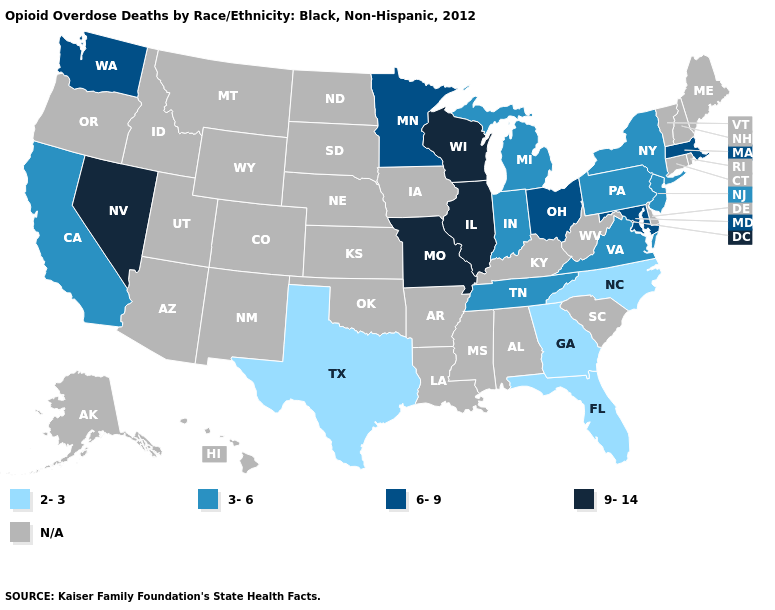Name the states that have a value in the range N/A?
Answer briefly. Alabama, Alaska, Arizona, Arkansas, Colorado, Connecticut, Delaware, Hawaii, Idaho, Iowa, Kansas, Kentucky, Louisiana, Maine, Mississippi, Montana, Nebraska, New Hampshire, New Mexico, North Dakota, Oklahoma, Oregon, Rhode Island, South Carolina, South Dakota, Utah, Vermont, West Virginia, Wyoming. Name the states that have a value in the range N/A?
Quick response, please. Alabama, Alaska, Arizona, Arkansas, Colorado, Connecticut, Delaware, Hawaii, Idaho, Iowa, Kansas, Kentucky, Louisiana, Maine, Mississippi, Montana, Nebraska, New Hampshire, New Mexico, North Dakota, Oklahoma, Oregon, Rhode Island, South Carolina, South Dakota, Utah, Vermont, West Virginia, Wyoming. What is the highest value in the West ?
Keep it brief. 9-14. Which states hav the highest value in the South?
Keep it brief. Maryland. Does Missouri have the highest value in the USA?
Write a very short answer. Yes. Name the states that have a value in the range 9-14?
Write a very short answer. Illinois, Missouri, Nevada, Wisconsin. Is the legend a continuous bar?
Keep it brief. No. What is the highest value in states that border Idaho?
Quick response, please. 9-14. What is the value of Virginia?
Short answer required. 3-6. Name the states that have a value in the range 3-6?
Keep it brief. California, Indiana, Michigan, New Jersey, New York, Pennsylvania, Tennessee, Virginia. What is the highest value in states that border New York?
Concise answer only. 6-9. Name the states that have a value in the range 6-9?
Be succinct. Maryland, Massachusetts, Minnesota, Ohio, Washington. Name the states that have a value in the range 9-14?
Write a very short answer. Illinois, Missouri, Nevada, Wisconsin. 